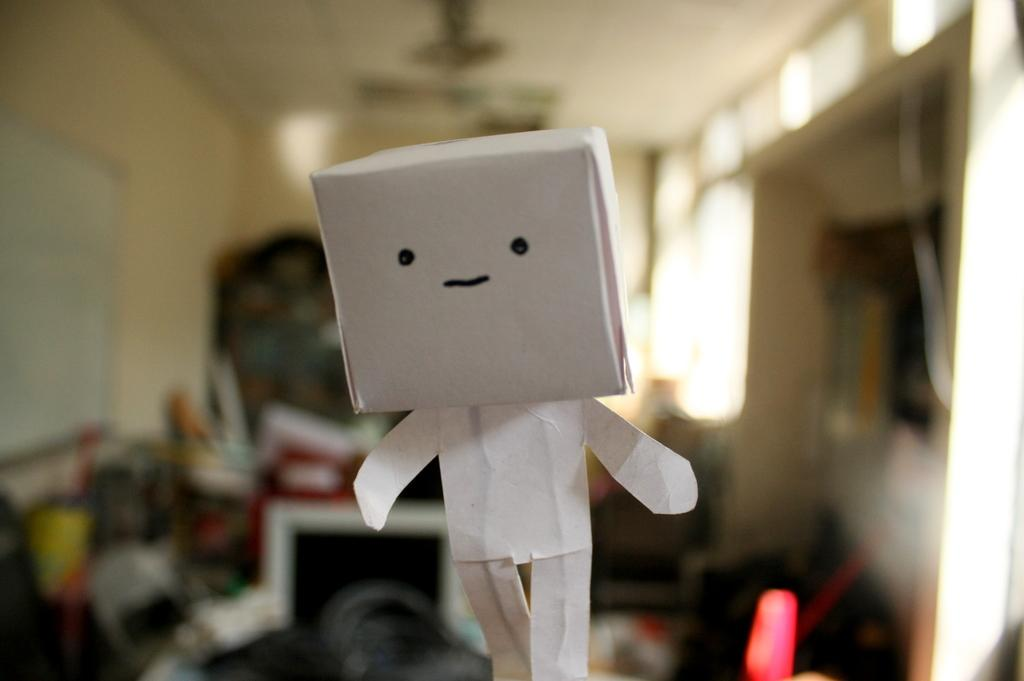What is the main color of the object in the image? The object in the image is white. What can be seen in the background of the image? There is a wall, a ceiling, and other objects in the background of the image. How is the background of the image depicted? The background of the image is blurred. Can you tell me how the mother and stranger are interacting in the image? There is no mother or stranger present in the image; it only features a white object and a blurred background. 